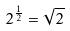<formula> <loc_0><loc_0><loc_500><loc_500>2 ^ { \frac { 1 } { 2 } } = \sqrt { 2 }</formula> 